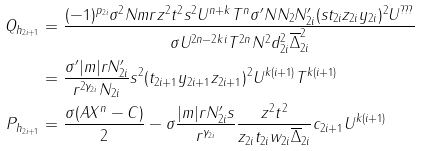<formula> <loc_0><loc_0><loc_500><loc_500>Q _ { h _ { 2 i + 1 } } & = \frac { ( - 1 ) ^ { p _ { 2 i } } \sigma ^ { 2 } N m r z ^ { 2 } t ^ { 2 } s ^ { 2 } U ^ { n + k } T ^ { n } \sigma ^ { \prime } N N _ { 2 } N _ { 2 i } ^ { \prime } ( s t _ { 2 i } z _ { 2 i } y _ { 2 i } ) ^ { 2 } U ^ { ? ? ? } } { \sigma U ^ { 2 n - 2 k i } T ^ { 2 n } N ^ { 2 } d _ { 2 i } ^ { 2 } \overline { \Delta } _ { 2 i } ^ { 2 } } \\ & = \frac { \sigma ^ { \prime } | m | r N _ { 2 i } ^ { \prime } } { r ^ { 2 \gamma _ { 2 i } } N _ { 2 i } } s ^ { 2 } ( t _ { 2 i + 1 } y _ { 2 i + 1 } z _ { 2 i + 1 } ) ^ { 2 } U ^ { k ( i + 1 ) } T ^ { k ( i + 1 ) } \\ P _ { h _ { 2 i + 1 } } & = \frac { \sigma ( A X ^ { n } - C ) } { 2 } - \sigma \frac { | m | r N _ { 2 i } ^ { \prime } s } { r ^ { \gamma _ { 2 i } } } \frac { z ^ { 2 } t ^ { 2 } } { z _ { 2 i } t _ { 2 i } w _ { 2 i } \overline { \Delta } _ { 2 i } } c _ { 2 i + 1 } U ^ { k ( i + 1 ) }</formula> 